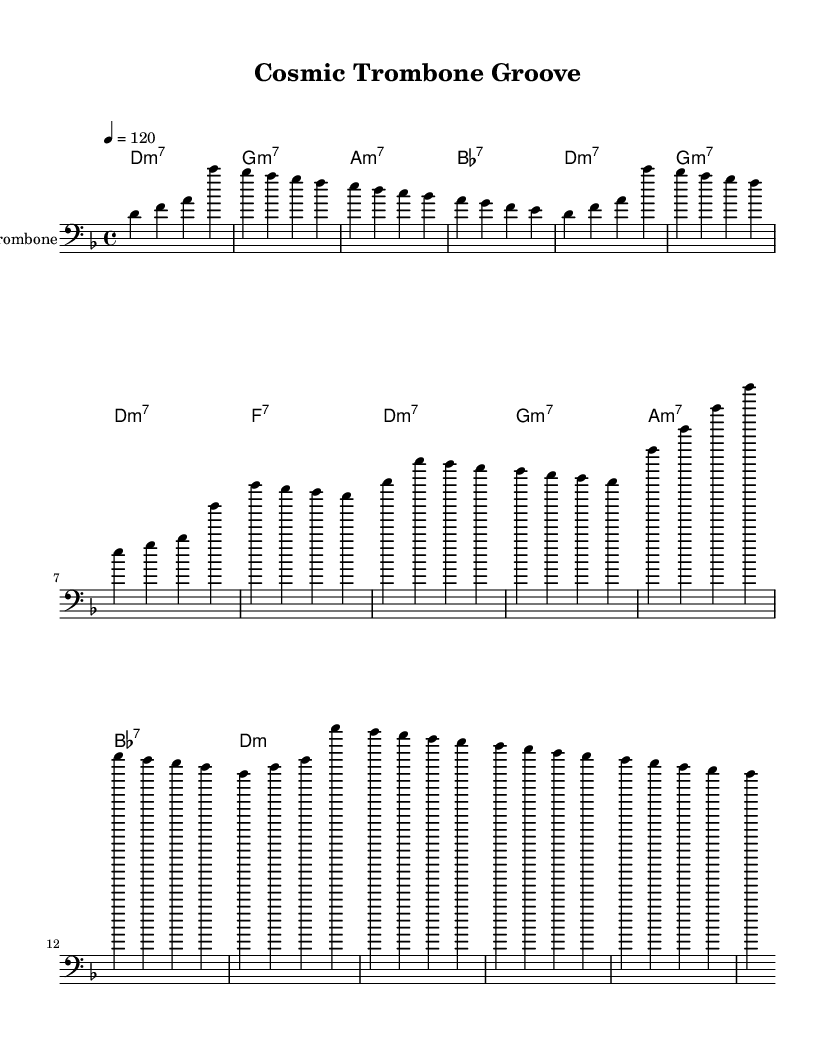what is the key signature of this music? The key signature is D minor, which contains one flat (B flat) and is indicated by the key signature at the beginning of the score.
Answer: D minor what is the time signature of this music? The time signature is 4/4, which means there are four beats in each measure and a quarter note receives one beat. This is shown right after the key signature.
Answer: 4/4 what is the tempo marking in this piece? The tempo marking is 120 beats per minute, indicated by the tempo marking "4 = 120" at the beginning.
Answer: 120 which chord starts the intro section? The intro section begins with a D minor 7 chord, which is shown as "d:m7" in the chord names above the staff.
Answer: D minor 7 how many measures are in the chorus section? The chorus section consists of four measures, as indicated by the number of groupings in the notation. Each measure is separated by vertical lines, making it easy to count.
Answer: 4 what type of jazz elements are incorporated into this Funk-fusion R&B piece? The piece incorporates free jazz elements, which often include improvisation and unconventional rhythms. In the context of this music, these influences can be inferred from the rhythm and flow of the sections.
Answer: Free jazz which note appears most frequently in the trombone part? The note 'g' appears most frequently throughout various sections of the trombone part. By scanning the music, one can count the occurrences of 'g' in the melody.
Answer: g 